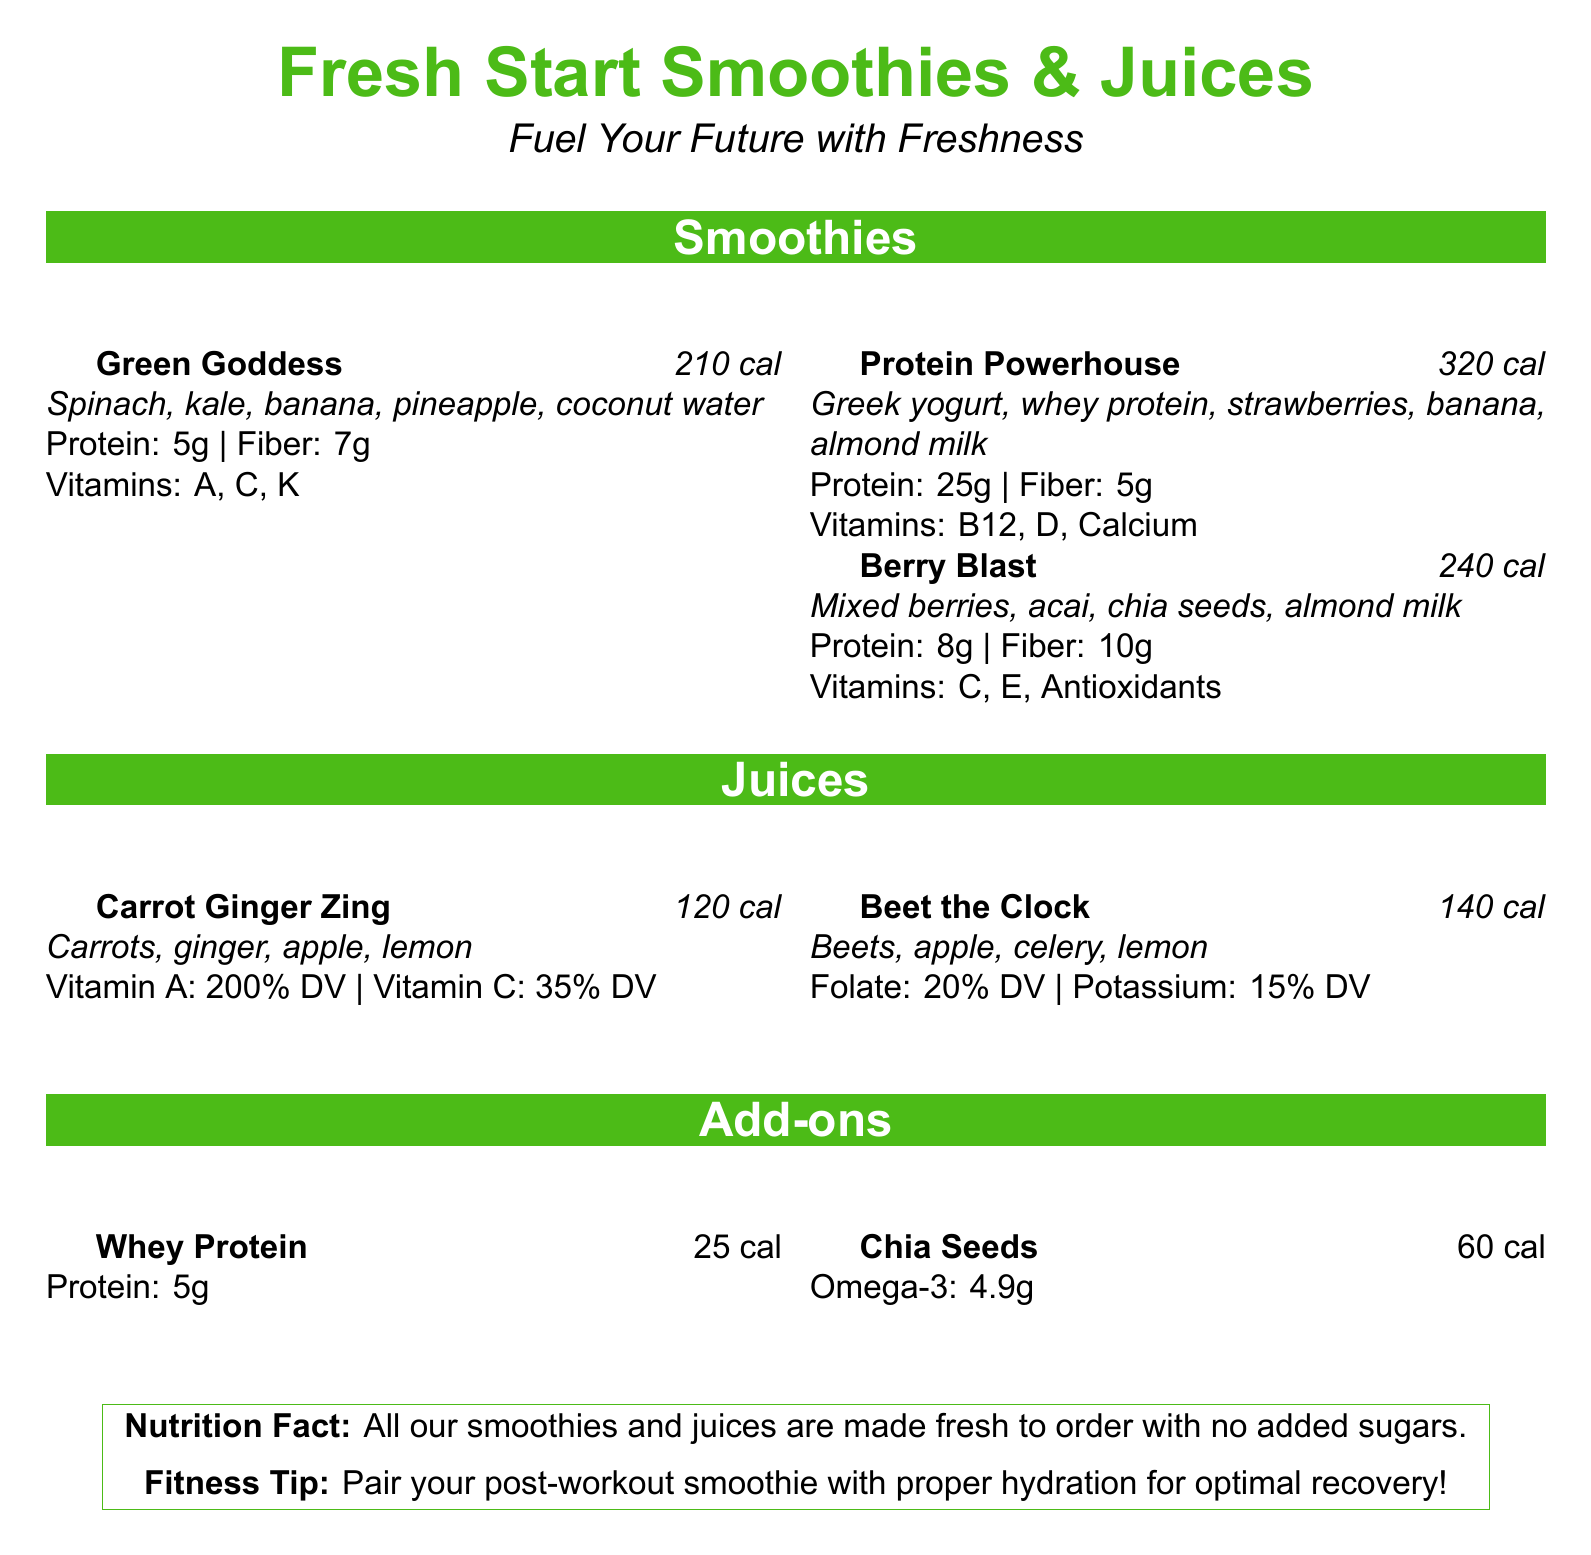What is the calorie count of the Green Goddess smoothie? The calorie count is listed directly next to the smoothie name in the menu.
Answer: 210 cal What are the main ingredients of the Protein Powerhouse smoothie? The ingredients are mentioned below the smoothie title and calorie count.
Answer: Greek yogurt, whey protein, strawberries, banana, almond milk How much protein is in the Berry Blast smoothie? The protein amount is specified in grams below the smoothie description.
Answer: 8g What percentage of daily value of Vitamin A is in the Carrot Ginger Zing juice? The daily value percentages for vitamins are listed next to each juice name.
Answer: 200% DV What is the total calorie count for both juices on the menu? The calorie counts for each juice are given, and adding them provides the total calorie count.
Answer: 260 cal Which smoothie has the highest calorie count? The calorie counts for each smoothie are listed, allowing comparison to find the highest.
Answer: Protein Powerhouse What are the add-ons available for smoothies? The add-ons and their details are listed in a separate section.
Answer: Whey Protein, Chia Seeds What is the fitness tip provided in the document? The fitness tip is located in the nutrition fact box at the bottom of the menu.
Answer: Pair your post-workout smoothie with proper hydration for optimal recovery! Which smoothie contains chia seeds as an ingredient? The ingredients for each smoothie list chia seeds specifically for one of them.
Answer: Berry Blast 